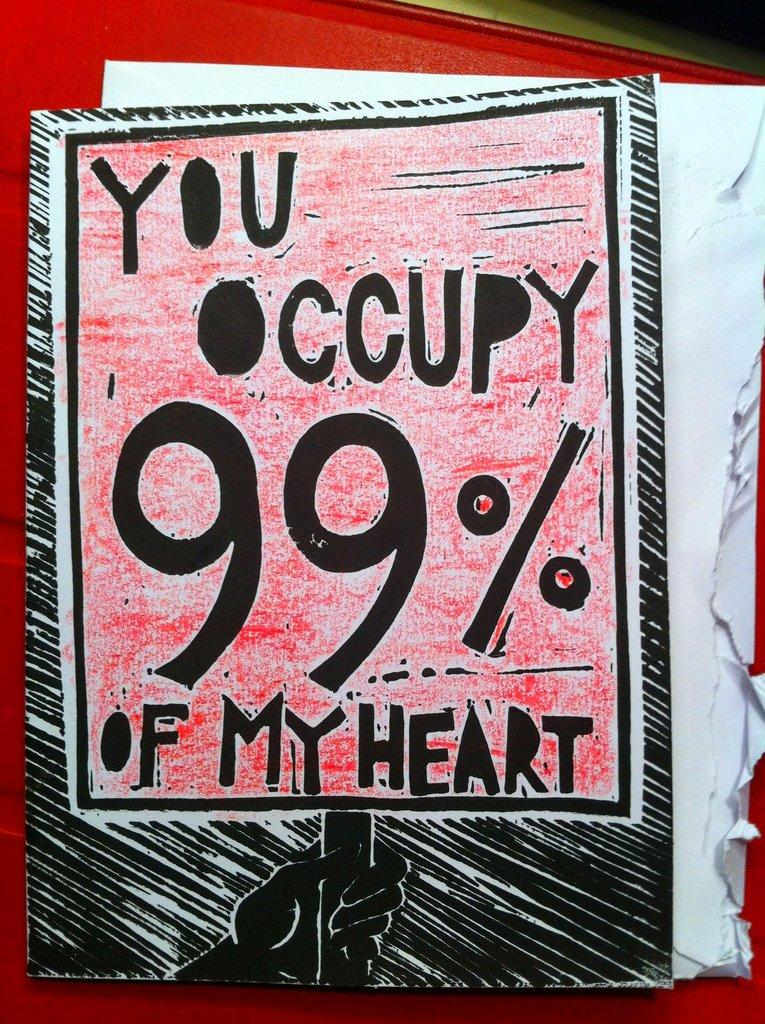Provide a one-sentence caption for the provided image. A sign taken from an envelope contains a play on the Occupy movement's slogan. 